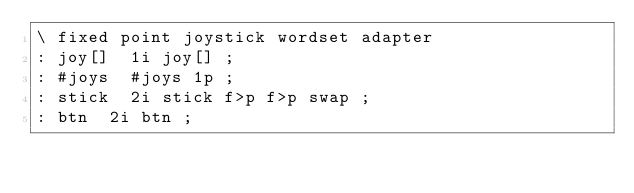Convert code to text. <code><loc_0><loc_0><loc_500><loc_500><_FORTRAN_>\ fixed point joystick wordset adapter
: joy[]  1i joy[] ;
: #joys  #joys 1p ;
: stick  2i stick f>p f>p swap ;
: btn  2i btn ;
</code> 